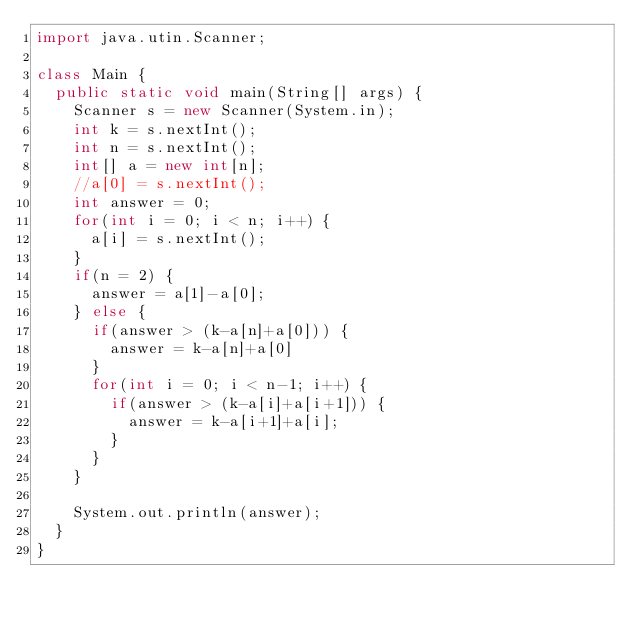<code> <loc_0><loc_0><loc_500><loc_500><_Java_>import java.utin.Scanner;

class Main {
  public static void main(String[] args) {
    Scanner s = new Scanner(System.in);
    int k = s.nextInt();
    int n = s.nextInt();
    int[] a = new int[n];
    //a[0] = s.nextInt();
    int answer = 0;
    for(int i = 0; i < n; i++) {
      a[i] = s.nextInt();
    }
    if(n = 2) {
      answer = a[1]-a[0];
    } else {
      if(answer > (k-a[n]+a[0])) {
        answer = k-a[n]+a[0]
      }
      for(int i = 0; i < n-1; i++) {
        if(answer > (k-a[i]+a[i+1])) {
          answer = k-a[i+1]+a[i];
        }
      }
    }

    System.out.println(answer);
  }
}</code> 